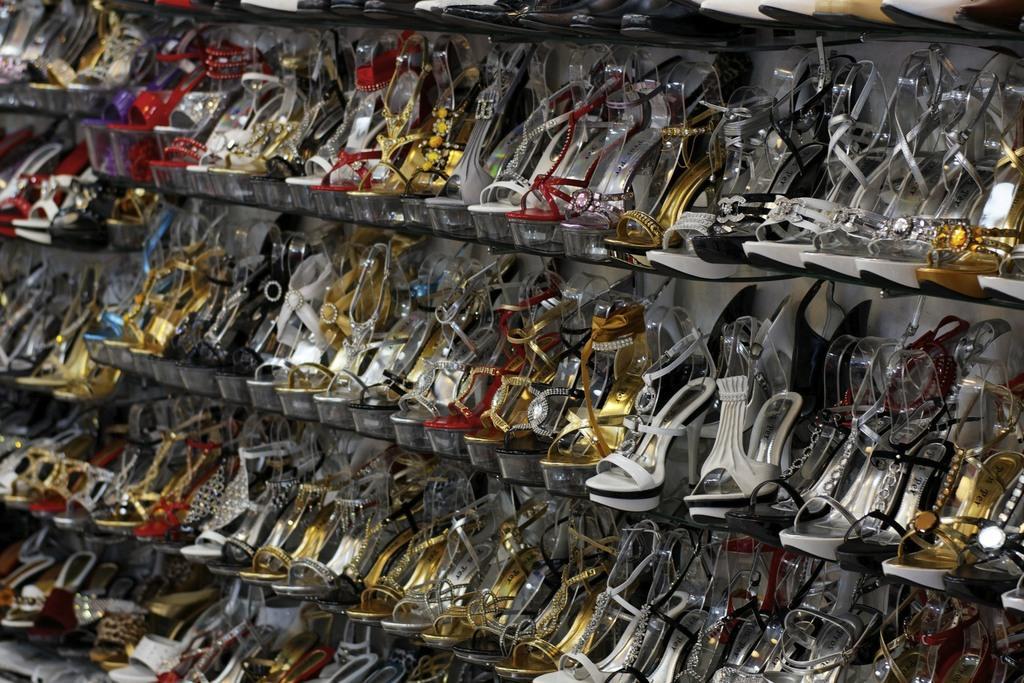Can you describe this image briefly? In the image we can see some footwear. Behind them there is wall. 